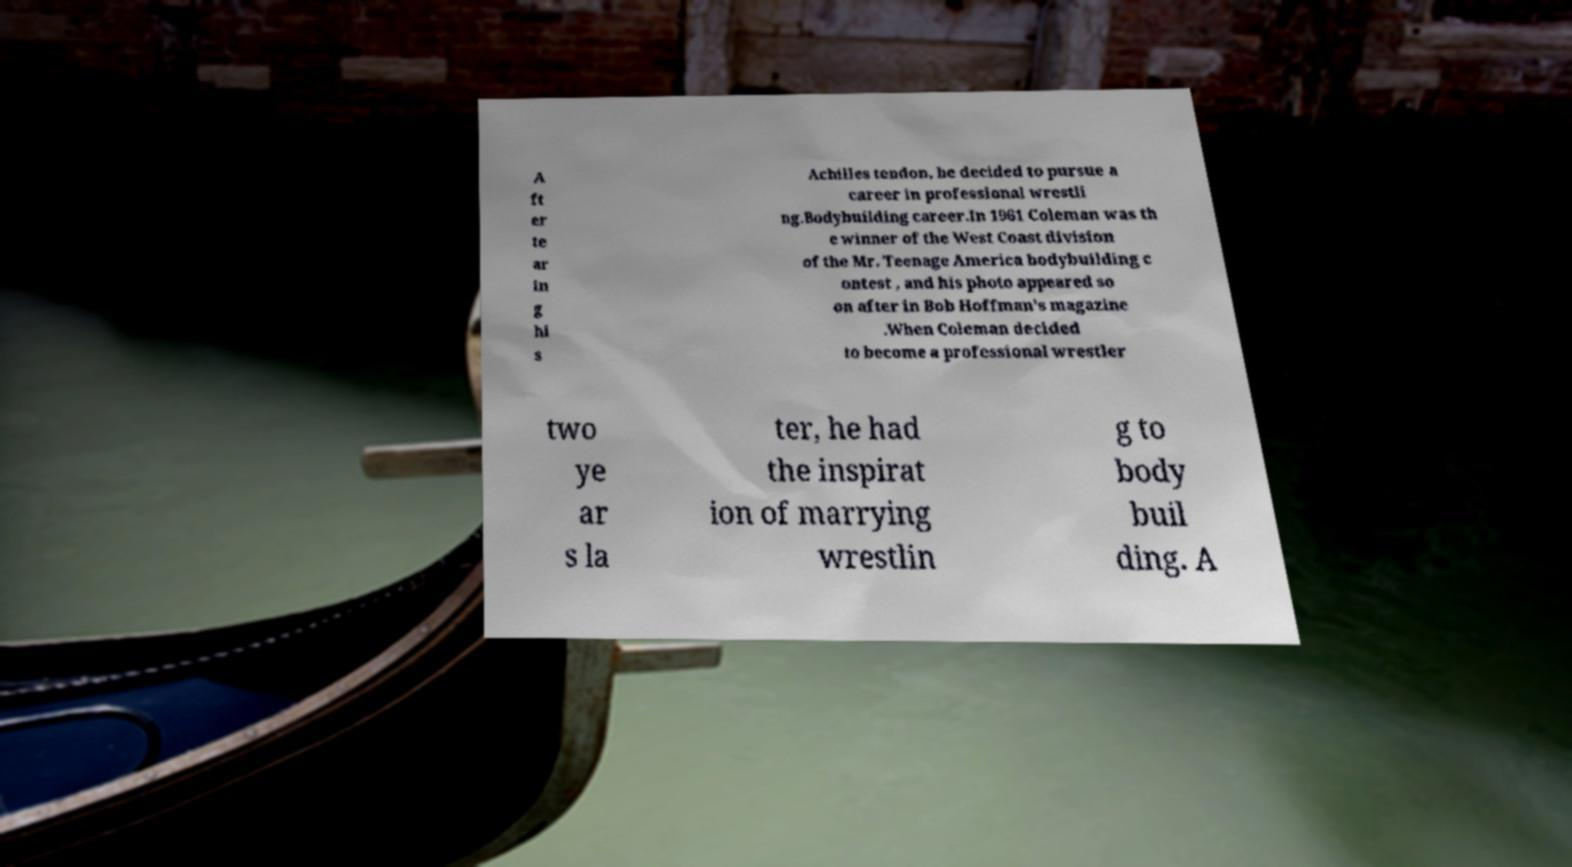Please read and relay the text visible in this image. What does it say? A ft er te ar in g hi s Achilles tendon, he decided to pursue a career in professional wrestli ng.Bodybuilding career.In 1961 Coleman was th e winner of the West Coast division of the Mr. Teenage America bodybuilding c ontest , and his photo appeared so on after in Bob Hoffman's magazine .When Coleman decided to become a professional wrestler two ye ar s la ter, he had the inspirat ion of marrying wrestlin g to body buil ding. A 